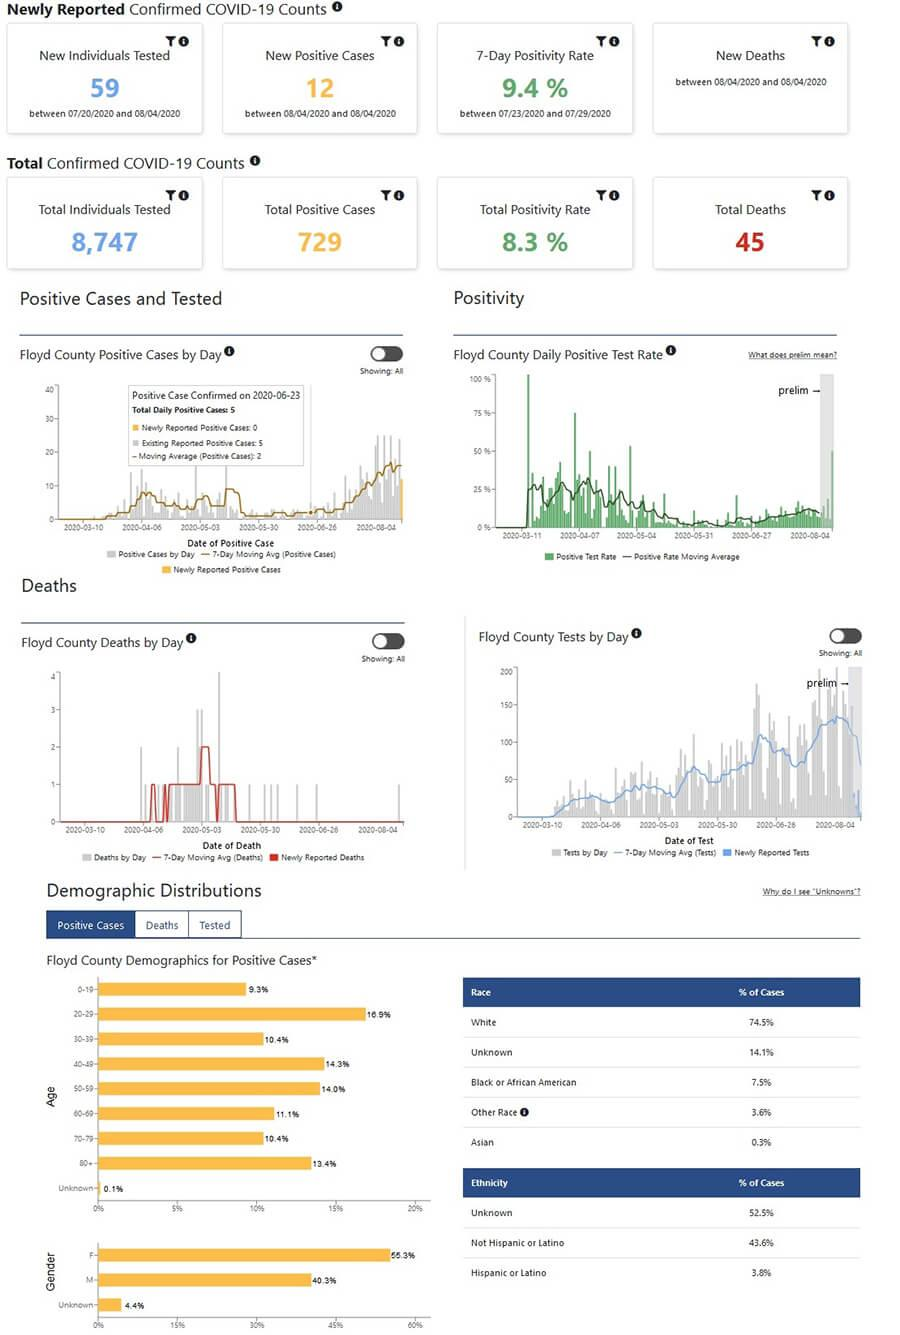Indicate a few pertinent items in this graphic. Approximately 36.6% of COVID-19 cases are among individuals under the age of 40. The least number of infected people belong to the age group of 0-9 years old. The percentage of COVID-19 cases among those aged 70 and above is 23.8%. A recent study has revealed that of the total number of COVID-19 infected individuals, 74.8% belong to the white and Asian race combination. According to the data, the Covid-19 infection rate among individuals aged 40-59 is 28.3%. 